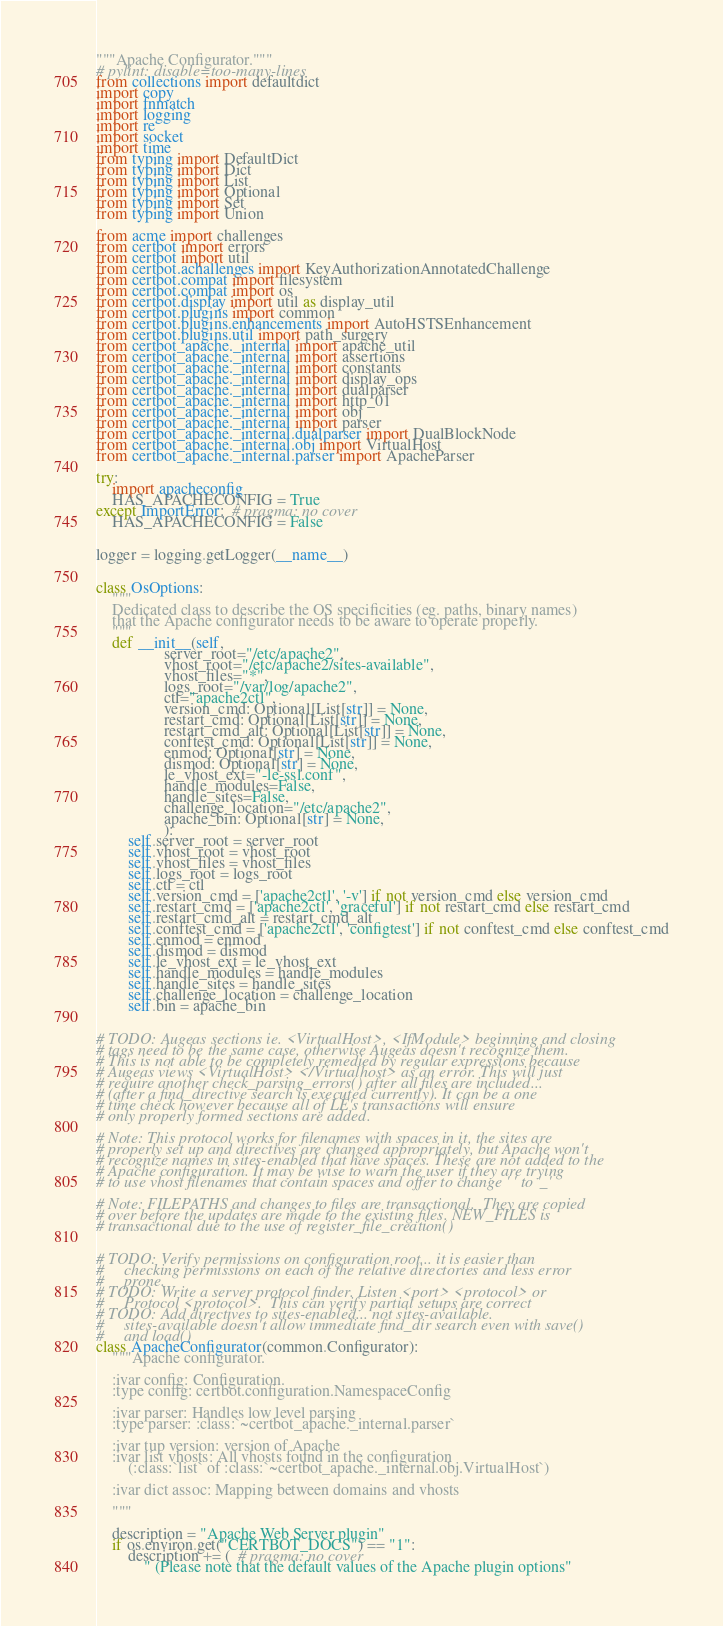Convert code to text. <code><loc_0><loc_0><loc_500><loc_500><_Python_>"""Apache Configurator."""
# pylint: disable=too-many-lines
from collections import defaultdict
import copy
import fnmatch
import logging
import re
import socket
import time
from typing import DefaultDict
from typing import Dict
from typing import List
from typing import Optional
from typing import Set
from typing import Union

from acme import challenges
from certbot import errors
from certbot import util
from certbot.achallenges import KeyAuthorizationAnnotatedChallenge
from certbot.compat import filesystem
from certbot.compat import os
from certbot.display import util as display_util
from certbot.plugins import common
from certbot.plugins.enhancements import AutoHSTSEnhancement
from certbot.plugins.util import path_surgery
from certbot_apache._internal import apache_util
from certbot_apache._internal import assertions
from certbot_apache._internal import constants
from certbot_apache._internal import display_ops
from certbot_apache._internal import dualparser
from certbot_apache._internal import http_01
from certbot_apache._internal import obj
from certbot_apache._internal import parser
from certbot_apache._internal.dualparser import DualBlockNode
from certbot_apache._internal.obj import VirtualHost
from certbot_apache._internal.parser import ApacheParser

try:
    import apacheconfig
    HAS_APACHECONFIG = True
except ImportError:  # pragma: no cover
    HAS_APACHECONFIG = False


logger = logging.getLogger(__name__)


class OsOptions:
    """
    Dedicated class to describe the OS specificities (eg. paths, binary names)
    that the Apache configurator needs to be aware to operate properly.
    """
    def __init__(self,
                 server_root="/etc/apache2",
                 vhost_root="/etc/apache2/sites-available",
                 vhost_files="*",
                 logs_root="/var/log/apache2",
                 ctl="apache2ctl",
                 version_cmd: Optional[List[str]] = None,
                 restart_cmd: Optional[List[str]] = None,
                 restart_cmd_alt: Optional[List[str]] = None,
                 conftest_cmd: Optional[List[str]] = None,
                 enmod: Optional[str] = None,
                 dismod: Optional[str] = None,
                 le_vhost_ext="-le-ssl.conf",
                 handle_modules=False,
                 handle_sites=False,
                 challenge_location="/etc/apache2",
                 apache_bin: Optional[str] = None,
                 ):
        self.server_root = server_root
        self.vhost_root = vhost_root
        self.vhost_files = vhost_files
        self.logs_root = logs_root
        self.ctl = ctl
        self.version_cmd = ['apache2ctl', '-v'] if not version_cmd else version_cmd
        self.restart_cmd = ['apache2ctl', 'graceful'] if not restart_cmd else restart_cmd
        self.restart_cmd_alt = restart_cmd_alt
        self.conftest_cmd = ['apache2ctl', 'configtest'] if not conftest_cmd else conftest_cmd
        self.enmod = enmod
        self.dismod = dismod
        self.le_vhost_ext = le_vhost_ext
        self.handle_modules = handle_modules
        self.handle_sites = handle_sites
        self.challenge_location = challenge_location
        self.bin = apache_bin


# TODO: Augeas sections ie. <VirtualHost>, <IfModule> beginning and closing
# tags need to be the same case, otherwise Augeas doesn't recognize them.
# This is not able to be completely remedied by regular expressions because
# Augeas views <VirtualHost> </Virtualhost> as an error. This will just
# require another check_parsing_errors() after all files are included...
# (after a find_directive search is executed currently). It can be a one
# time check however because all of LE's transactions will ensure
# only properly formed sections are added.

# Note: This protocol works for filenames with spaces in it, the sites are
# properly set up and directives are changed appropriately, but Apache won't
# recognize names in sites-enabled that have spaces. These are not added to the
# Apache configuration. It may be wise to warn the user if they are trying
# to use vhost filenames that contain spaces and offer to change ' ' to '_'

# Note: FILEPATHS and changes to files are transactional.  They are copied
# over before the updates are made to the existing files. NEW_FILES is
# transactional due to the use of register_file_creation()


# TODO: Verify permissions on configuration root... it is easier than
#     checking permissions on each of the relative directories and less error
#     prone.
# TODO: Write a server protocol finder. Listen <port> <protocol> or
#     Protocol <protocol>.  This can verify partial setups are correct
# TODO: Add directives to sites-enabled... not sites-available.
#     sites-available doesn't allow immediate find_dir search even with save()
#     and load()
class ApacheConfigurator(common.Configurator):
    """Apache configurator.

    :ivar config: Configuration.
    :type config: certbot.configuration.NamespaceConfig

    :ivar parser: Handles low level parsing
    :type parser: :class:`~certbot_apache._internal.parser`

    :ivar tup version: version of Apache
    :ivar list vhosts: All vhosts found in the configuration
        (:class:`list` of :class:`~certbot_apache._internal.obj.VirtualHost`)

    :ivar dict assoc: Mapping between domains and vhosts

    """

    description = "Apache Web Server plugin"
    if os.environ.get("CERTBOT_DOCS") == "1":
        description += (  # pragma: no cover
            " (Please note that the default values of the Apache plugin options"</code> 